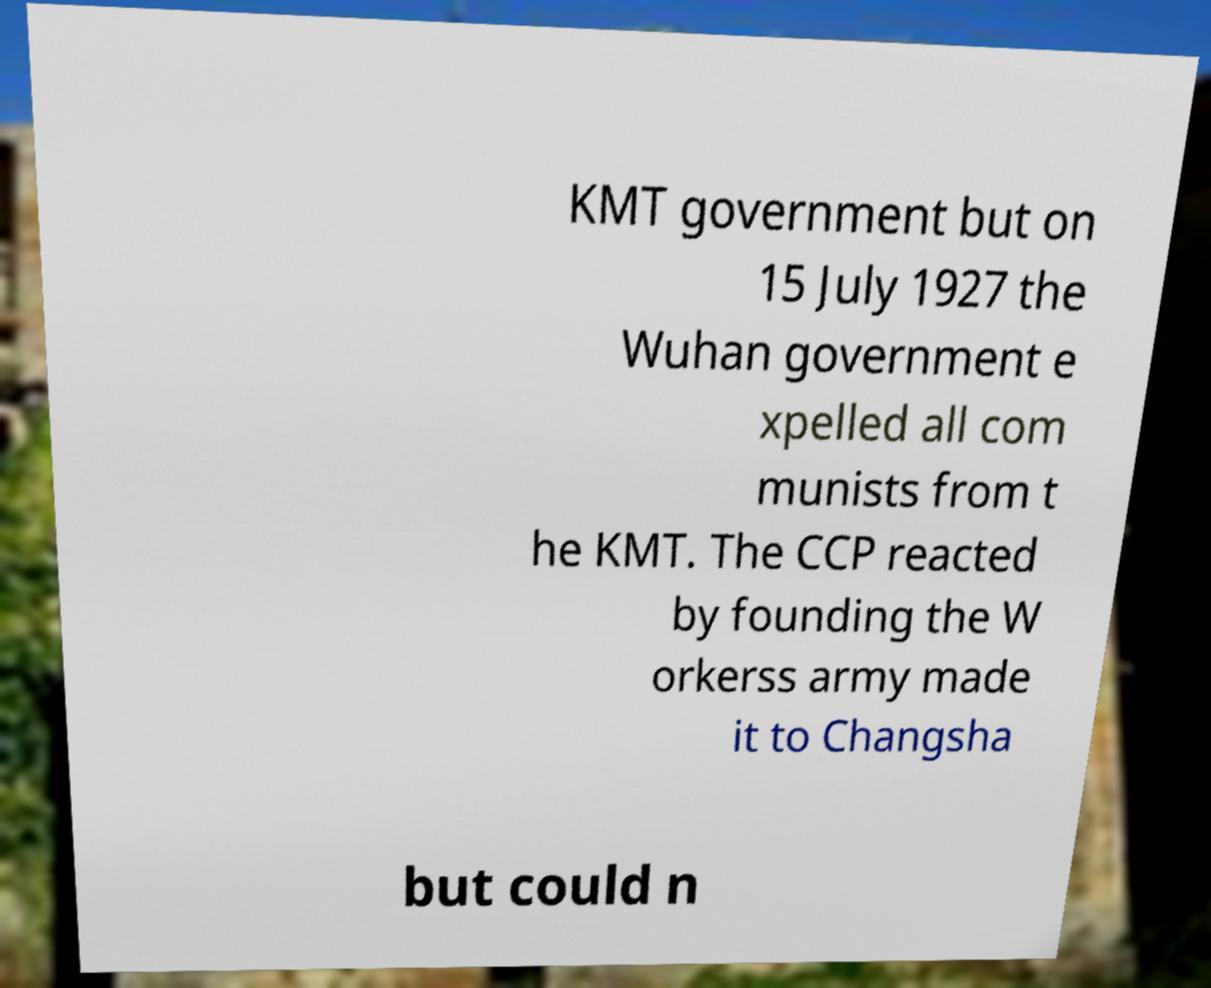Could you extract and type out the text from this image? KMT government but on 15 July 1927 the Wuhan government e xpelled all com munists from t he KMT. The CCP reacted by founding the W orkerss army made it to Changsha but could n 